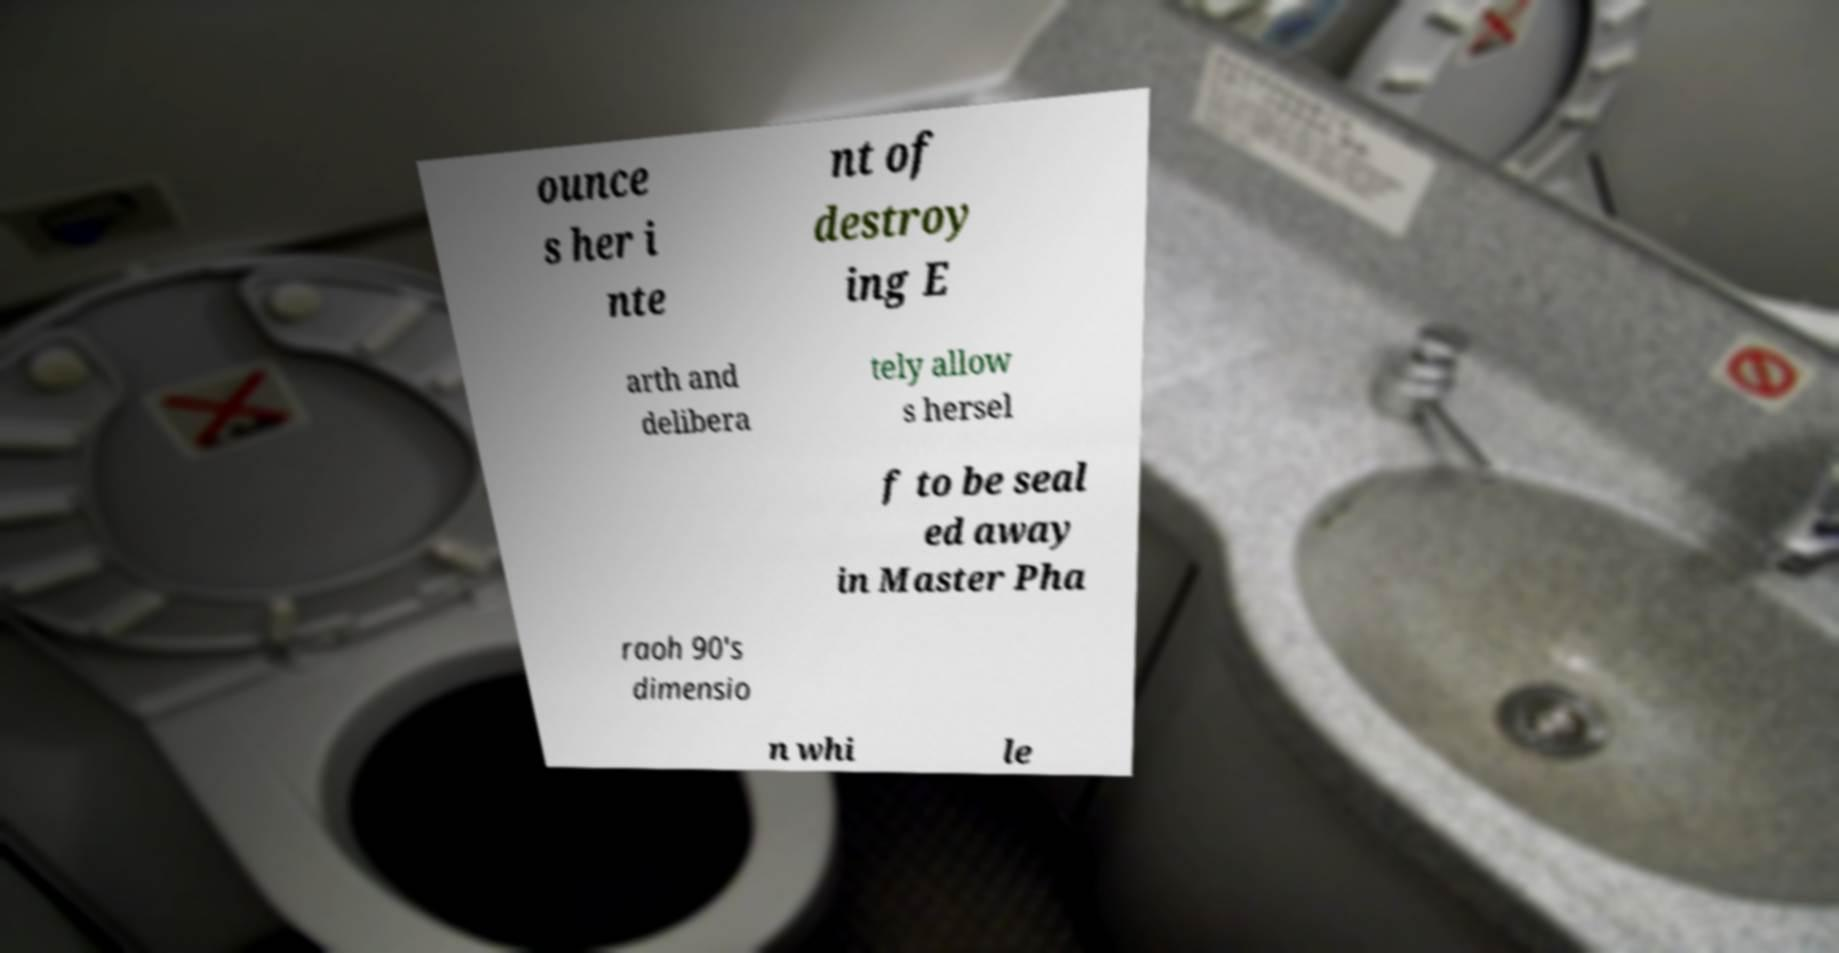Please identify and transcribe the text found in this image. ounce s her i nte nt of destroy ing E arth and delibera tely allow s hersel f to be seal ed away in Master Pha raoh 90's dimensio n whi le 